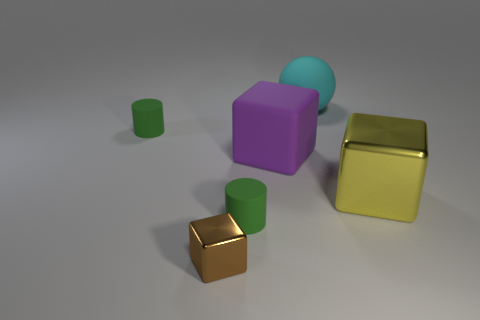Add 1 big green metal balls. How many objects exist? 7 Subtract all cylinders. How many objects are left? 4 Add 1 tiny green objects. How many tiny green objects exist? 3 Subtract 0 red cylinders. How many objects are left? 6 Subtract all cyan rubber cylinders. Subtract all large rubber spheres. How many objects are left? 5 Add 6 large purple objects. How many large purple objects are left? 7 